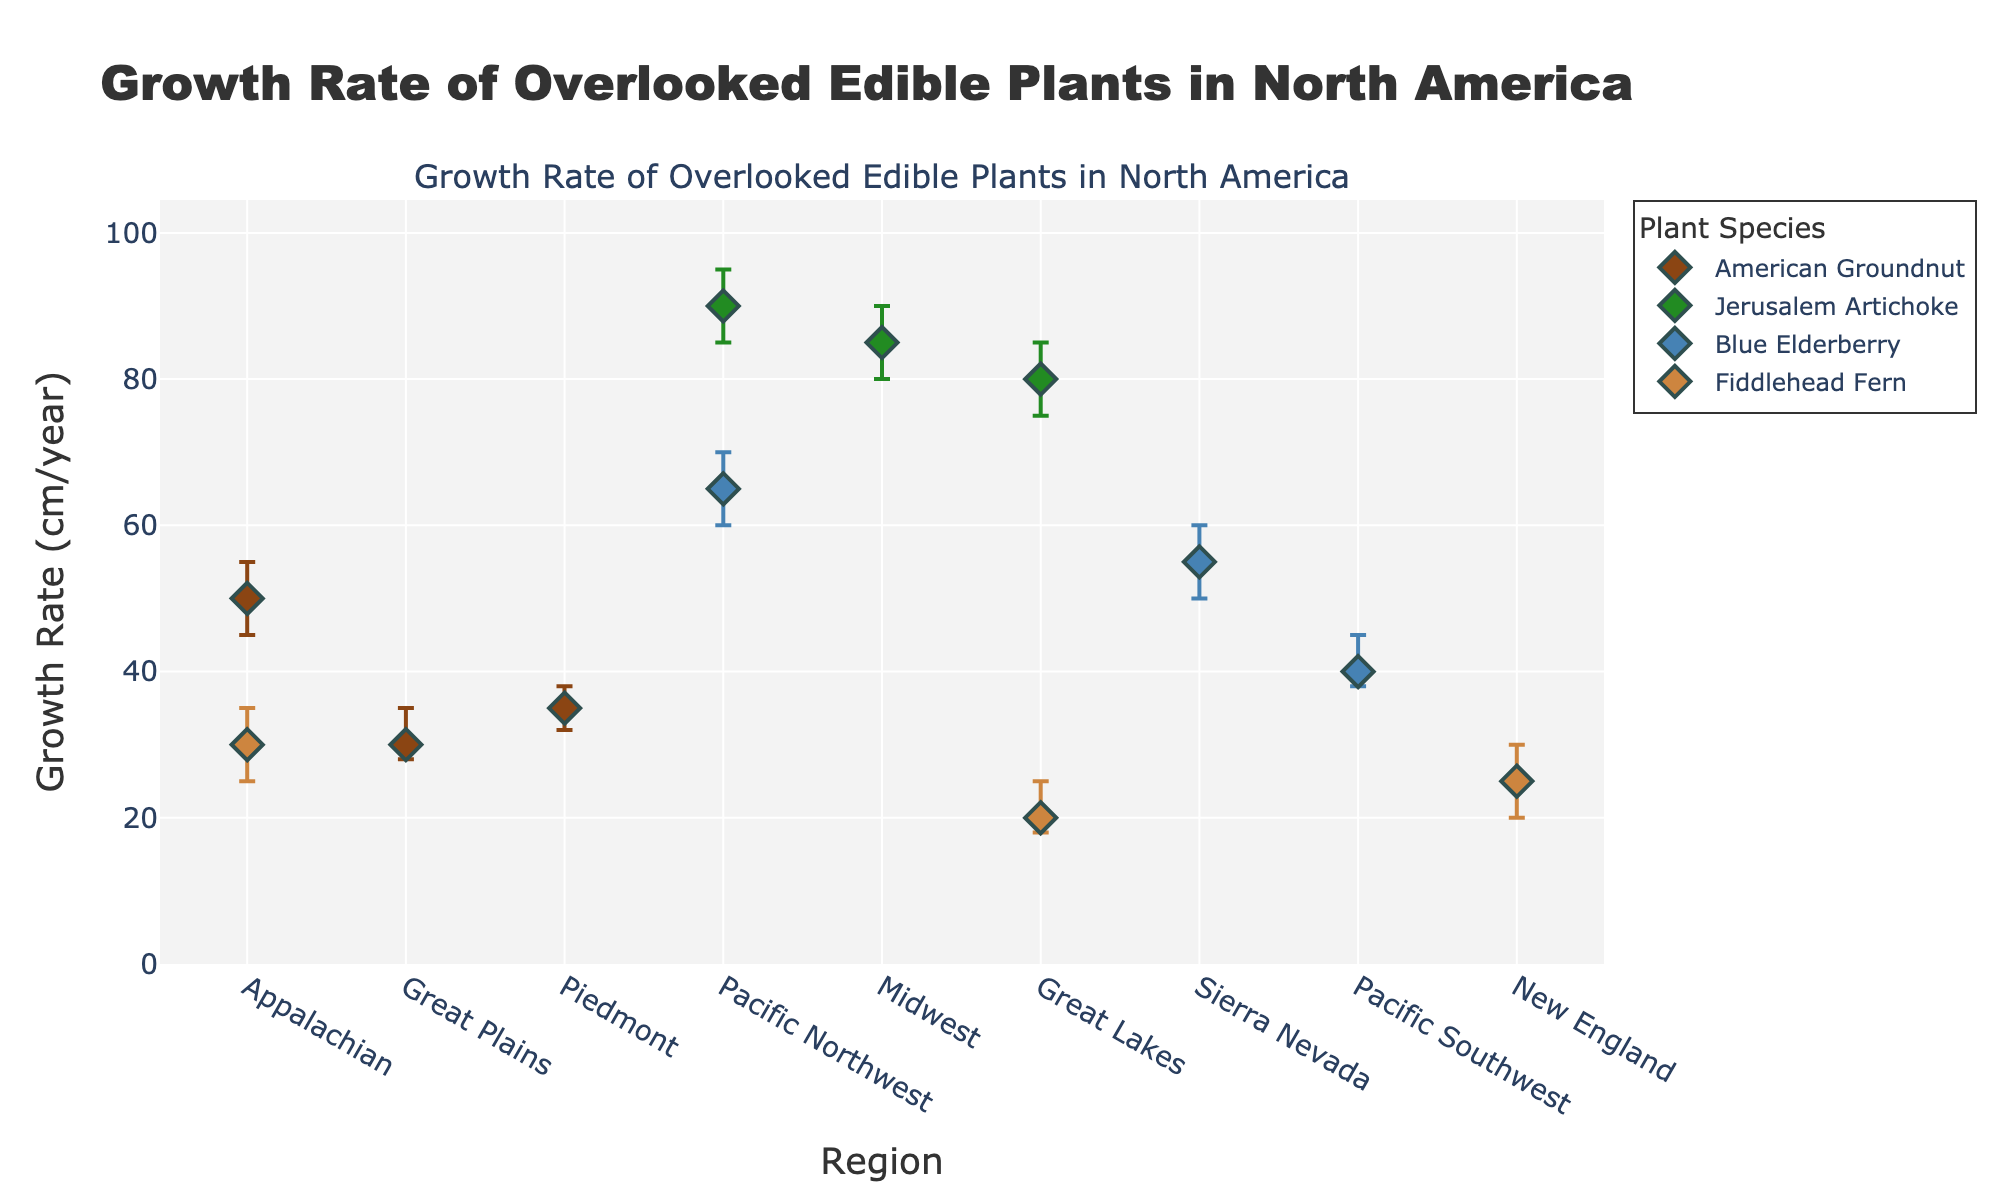What's the title of the figure? The title is generally found at the top of the figure and describes what the chart represents.
Answer: Growth Rate of Overlooked Edible Plants in North America What is the maximum mean growth rate observed for Jerusalem Artichoke? To find the maximum mean growth rate for Jerusalem Artichoke, look at the data points for this plant and identify the highest mean value. In this case, it is in the Pacific Northwest.
Answer: 90 cm/year Which plant shows the lowest environmental impact rating on the chart? Each data point includes information about the environmental impact rating. Blue Elderberry in the Sierra Nevada and Pacific Northwest regions shows the lowest rating of 1.
Answer: Blue Elderberry What is the growth rate range for American Groundnut in the Appalachian region? The range can be determined by looking at the lower and upper confidence intervals for the Appalachian region data point of American Groundnut.
Answer: 45 to 55 cm/year Which region shows the highest growth rate for Blue Elderberry? Look at all data points for Blue Elderberry and identify the region with the highest mean growth rate. This occurs in the Pacific Northwest.
Answer: Pacific Northwest How does the growth rate of Fiddlehead Fern in New England compare to that in the Appalachian region? To compare, look at the mean growth rates for Fiddlehead Fern in both regions. New England has a mean rate of 25 cm/year, while the Appalachian region has a mean rate of 30 cm/year.
Answer: The growth rate in the Appalachian region is higher What is the average mean growth rate of Jerusalem Artichoke across the three regions presented? Add the mean growth rates of Jerusalem Artichoke from the Pacific Northwest, Midwest, and Great Lakes regions and divide by the number of regions (3).
Answer: (90 + 85 + 80) / 3 = 85 cm/year Which plant has the most consistent growth rate across different regions? To find the most consistent growth rate, look at the size of the confidence intervals. The plant with the smallest confidence intervals overall is Jerusalem Artichoke.
Answer: Jerusalem Artichoke How does the environmental impact rating of American Groundnut in the Great Plains compare to that in the Piedmont region? Compare the environmental impact ratings. The Great Plains have a rating of 4, while the Piedmont has a rating of 3.
Answer: The Great Plains has a higher environmental impact rating Identify the plant and region with the highest mean growth rate and the corresponding environmental impact rating. Look for the highest data point for mean growth rate across all regions and plants. Check the accompanying environmental impact rating.
Answer: Jerusalem Artichoke in the Pacific Northwest, rating 2 